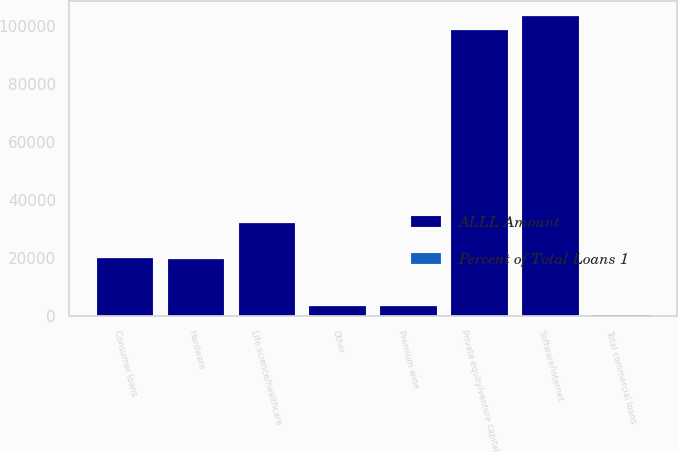<chart> <loc_0><loc_0><loc_500><loc_500><stacked_bar_chart><ecel><fcel>Software/internet<fcel>Hardware<fcel>Private equity/venture capital<fcel>Life science/healthcare<fcel>Premium wine<fcel>Other<fcel>Total commercial loans<fcel>Consumer loans<nl><fcel>ALLL Amount<fcel>103567<fcel>19725<fcel>98581<fcel>32180<fcel>3355<fcel>3558<fcel>89.4<fcel>19937<nl><fcel>Percent of Total Loans 1<fcel>21.8<fcel>4.4<fcel>49.5<fcel>8.6<fcel>3.4<fcel>1.7<fcel>89.4<fcel>10.6<nl></chart> 